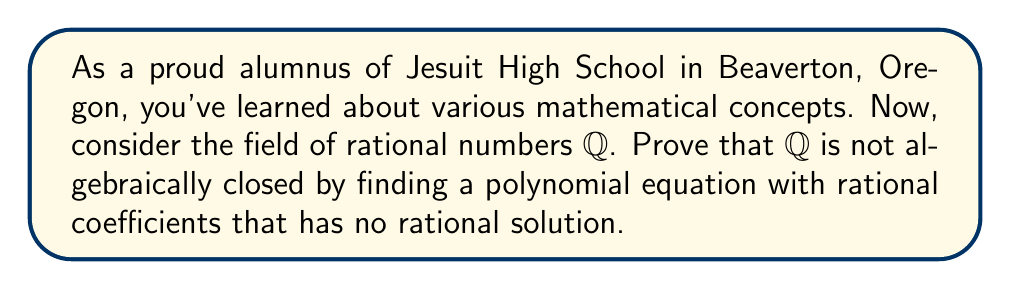Can you solve this math problem? Let's approach this step-by-step:

1) To prove that $\mathbb{Q}$ is not algebraically closed, we need to find a polynomial equation with rational coefficients that has no rational solution.

2) One of the simplest such equations is:

   $$x^2 = 2$$

3) Let's prove that this equation has no rational solution:

   a) Assume, for the sake of contradiction, that there exists a rational solution $\frac{p}{q}$ where $p$ and $q$ are integers with no common factors (i.e., in lowest terms).

   b) If $\frac{p}{q}$ is a solution, then:

      $$(\frac{p}{q})^2 = 2$$

   c) Simplifying:

      $$\frac{p^2}{q^2} = 2$$

   d) Cross-multiplying:

      $$p^2 = 2q^2$$

   e) This implies that $p^2$ is even, which means $p$ must be even (since odd squared is odd).

   f) If $p$ is even, we can write $p = 2k$ for some integer $k$.

   g) Substituting back:

      $$(2k)^2 = 2q^2$$
      $$4k^2 = 2q^2$$
      $$2k^2 = q^2$$

   h) This implies that $q^2$ is even, which means $q$ must be even.

   i) But if both $p$ and $q$ are even, they have a common factor of 2, contradicting our initial assumption that $\frac{p}{q}$ was in lowest terms.

4) This contradiction proves that there is no rational solution to $x^2 = 2$.

5) Therefore, we have found a polynomial equation with rational coefficients ($x^2 - 2 = 0$) that has no rational solution.

6) This proves that the field of rational numbers is not algebraically closed.
Answer: $\mathbb{Q}$ is not algebraically closed because $x^2 = 2$ has no rational solution. 